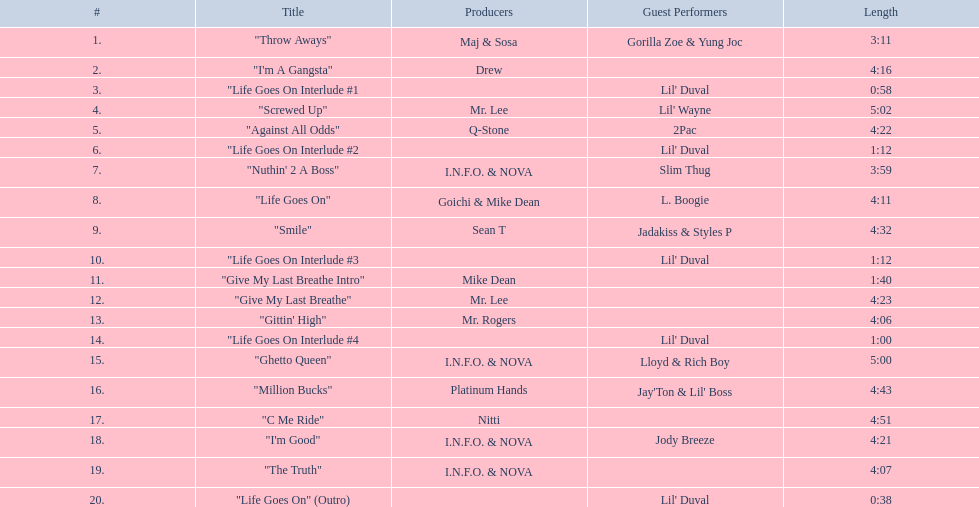I'm looking to parse the entire table for insights. Could you assist me with that? {'header': ['#', 'Title', 'Producers', 'Guest Performers', 'Length'], 'rows': [['1.', '"Throw Aways"', 'Maj & Sosa', 'Gorilla Zoe & Yung Joc', '3:11'], ['2.', '"I\'m A Gangsta"', 'Drew', '', '4:16'], ['3.', '"Life Goes On Interlude #1', '', "Lil' Duval", '0:58'], ['4.', '"Screwed Up"', 'Mr. Lee', "Lil' Wayne", '5:02'], ['5.', '"Against All Odds"', 'Q-Stone', '2Pac', '4:22'], ['6.', '"Life Goes On Interlude #2', '', "Lil' Duval", '1:12'], ['7.', '"Nuthin\' 2 A Boss"', 'I.N.F.O. & NOVA', 'Slim Thug', '3:59'], ['8.', '"Life Goes On"', 'Goichi & Mike Dean', 'L. Boogie', '4:11'], ['9.', '"Smile"', 'Sean T', 'Jadakiss & Styles P', '4:32'], ['10.', '"Life Goes On Interlude #3', '', "Lil' Duval", '1:12'], ['11.', '"Give My Last Breathe Intro"', 'Mike Dean', '', '1:40'], ['12.', '"Give My Last Breathe"', 'Mr. Lee', '', '4:23'], ['13.', '"Gittin\' High"', 'Mr. Rogers', '', '4:06'], ['14.', '"Life Goes On Interlude #4', '', "Lil' Duval", '1:00'], ['15.', '"Ghetto Queen"', 'I.N.F.O. & NOVA', 'Lloyd & Rich Boy', '5:00'], ['16.', '"Million Bucks"', 'Platinum Hands', "Jay'Ton & Lil' Boss", '4:43'], ['17.', '"C Me Ride"', 'Nitti', '', '4:51'], ['18.', '"I\'m Good"', 'I.N.F.O. & NOVA', 'Jody Breeze', '4:21'], ['19.', '"The Truth"', 'I.N.F.O. & NOVA', '', '4:07'], ['20.', '"Life Goes On" (Outro)', '', "Lil' Duval", '0:38']]} What tracks appear on the album life goes on (trae album)? "Throw Aways", "I'm A Gangsta", "Life Goes On Interlude #1, "Screwed Up", "Against All Odds", "Life Goes On Interlude #2, "Nuthin' 2 A Boss", "Life Goes On", "Smile", "Life Goes On Interlude #3, "Give My Last Breathe Intro", "Give My Last Breathe", "Gittin' High", "Life Goes On Interlude #4, "Ghetto Queen", "Million Bucks", "C Me Ride", "I'm Good", "The Truth", "Life Goes On" (Outro). Which of these songs are at least 5 minutes long? "Screwed Up", "Ghetto Queen". Of these two songs over 5 minutes long, which is longer? "Screwed Up". How long is this track? 5:02. 